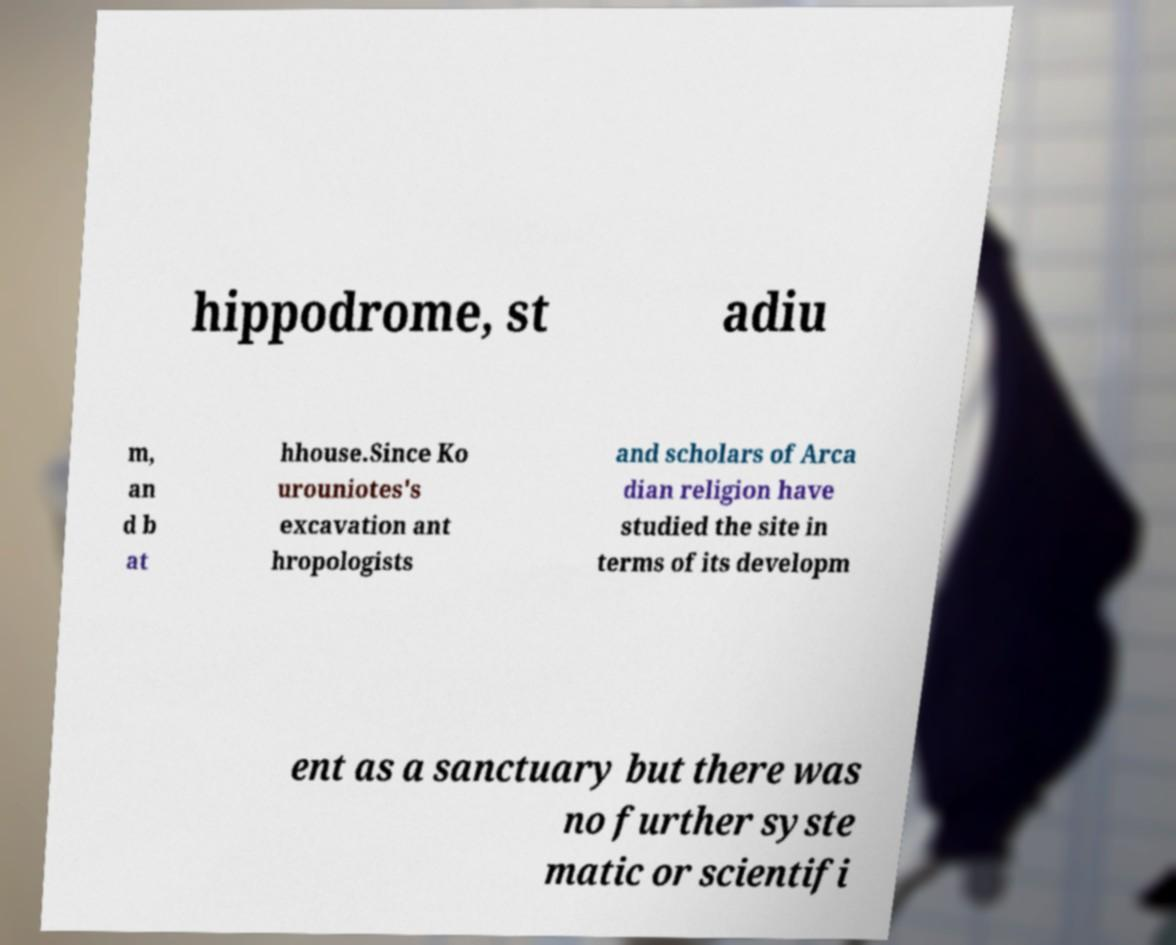Please identify and transcribe the text found in this image. hippodrome, st adiu m, an d b at hhouse.Since Ko urouniotes's excavation ant hropologists and scholars of Arca dian religion have studied the site in terms of its developm ent as a sanctuary but there was no further syste matic or scientifi 